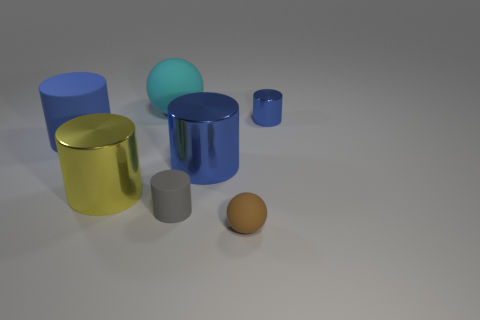What is the color of the big matte object that is to the left of the matte sphere that is behind the large yellow shiny object on the left side of the tiny blue shiny thing?
Provide a short and direct response. Blue. Are the small brown object and the gray cylinder made of the same material?
Offer a terse response. Yes. What number of green things are either large cylinders or tiny metal cylinders?
Make the answer very short. 0. There is a large ball; what number of small balls are behind it?
Offer a very short reply. 0. Are there more shiny cylinders than big cyan spheres?
Provide a succinct answer. Yes. What shape is the small object that is behind the big cylinder that is on the left side of the big yellow shiny thing?
Make the answer very short. Cylinder. Does the small matte sphere have the same color as the large ball?
Offer a terse response. No. Is the number of blue metal cylinders that are to the right of the large matte ball greater than the number of small brown rubber objects?
Keep it short and to the point. Yes. There is a metallic cylinder that is on the right side of the brown rubber ball; how many small blue things are to the right of it?
Ensure brevity in your answer.  0. Are the sphere behind the brown rubber thing and the blue thing that is right of the small brown matte object made of the same material?
Your answer should be very brief. No. 